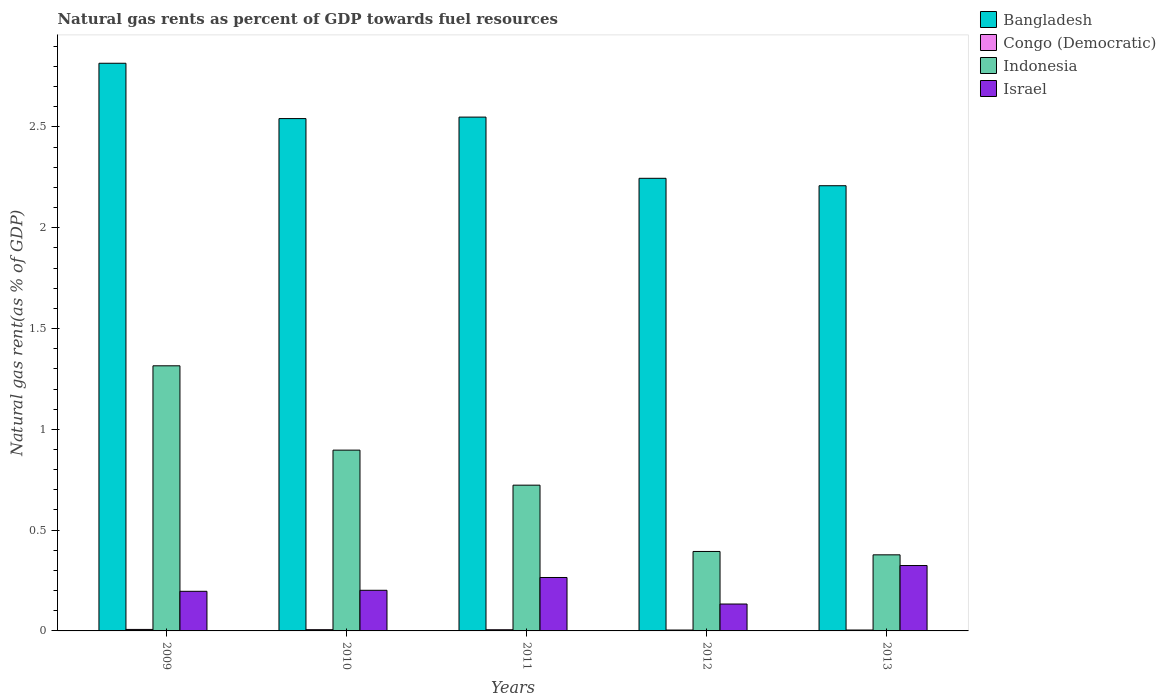How many different coloured bars are there?
Ensure brevity in your answer.  4. Are the number of bars on each tick of the X-axis equal?
Provide a succinct answer. Yes. In how many cases, is the number of bars for a given year not equal to the number of legend labels?
Make the answer very short. 0. What is the natural gas rent in Congo (Democratic) in 2009?
Your answer should be very brief. 0.01. Across all years, what is the maximum natural gas rent in Congo (Democratic)?
Offer a very short reply. 0.01. Across all years, what is the minimum natural gas rent in Bangladesh?
Make the answer very short. 2.21. In which year was the natural gas rent in Israel maximum?
Provide a short and direct response. 2013. In which year was the natural gas rent in Congo (Democratic) minimum?
Ensure brevity in your answer.  2012. What is the total natural gas rent in Indonesia in the graph?
Provide a succinct answer. 3.71. What is the difference between the natural gas rent in Bangladesh in 2011 and that in 2013?
Provide a succinct answer. 0.34. What is the difference between the natural gas rent in Bangladesh in 2011 and the natural gas rent in Israel in 2012?
Your answer should be compact. 2.42. What is the average natural gas rent in Congo (Democratic) per year?
Make the answer very short. 0.01. In the year 2009, what is the difference between the natural gas rent in Israel and natural gas rent in Congo (Democratic)?
Make the answer very short. 0.19. What is the ratio of the natural gas rent in Israel in 2011 to that in 2013?
Provide a short and direct response. 0.82. Is the difference between the natural gas rent in Israel in 2011 and 2012 greater than the difference between the natural gas rent in Congo (Democratic) in 2011 and 2012?
Give a very brief answer. Yes. What is the difference between the highest and the second highest natural gas rent in Israel?
Ensure brevity in your answer.  0.06. What is the difference between the highest and the lowest natural gas rent in Israel?
Give a very brief answer. 0.19. In how many years, is the natural gas rent in Bangladesh greater than the average natural gas rent in Bangladesh taken over all years?
Ensure brevity in your answer.  3. Is the sum of the natural gas rent in Israel in 2011 and 2012 greater than the maximum natural gas rent in Bangladesh across all years?
Ensure brevity in your answer.  No. Is it the case that in every year, the sum of the natural gas rent in Israel and natural gas rent in Bangladesh is greater than the sum of natural gas rent in Indonesia and natural gas rent in Congo (Democratic)?
Offer a terse response. Yes. What does the 1st bar from the right in 2012 represents?
Your response must be concise. Israel. Is it the case that in every year, the sum of the natural gas rent in Bangladesh and natural gas rent in Israel is greater than the natural gas rent in Congo (Democratic)?
Your response must be concise. Yes. How many years are there in the graph?
Provide a succinct answer. 5. What is the difference between two consecutive major ticks on the Y-axis?
Give a very brief answer. 0.5. Are the values on the major ticks of Y-axis written in scientific E-notation?
Your answer should be very brief. No. Does the graph contain grids?
Your answer should be very brief. No. How many legend labels are there?
Make the answer very short. 4. What is the title of the graph?
Keep it short and to the point. Natural gas rents as percent of GDP towards fuel resources. What is the label or title of the Y-axis?
Make the answer very short. Natural gas rent(as % of GDP). What is the Natural gas rent(as % of GDP) in Bangladesh in 2009?
Your response must be concise. 2.82. What is the Natural gas rent(as % of GDP) in Congo (Democratic) in 2009?
Your answer should be compact. 0.01. What is the Natural gas rent(as % of GDP) in Indonesia in 2009?
Make the answer very short. 1.32. What is the Natural gas rent(as % of GDP) of Israel in 2009?
Offer a very short reply. 0.2. What is the Natural gas rent(as % of GDP) in Bangladesh in 2010?
Keep it short and to the point. 2.54. What is the Natural gas rent(as % of GDP) in Congo (Democratic) in 2010?
Provide a short and direct response. 0.01. What is the Natural gas rent(as % of GDP) of Indonesia in 2010?
Make the answer very short. 0.9. What is the Natural gas rent(as % of GDP) in Israel in 2010?
Make the answer very short. 0.2. What is the Natural gas rent(as % of GDP) in Bangladesh in 2011?
Make the answer very short. 2.55. What is the Natural gas rent(as % of GDP) in Congo (Democratic) in 2011?
Give a very brief answer. 0.01. What is the Natural gas rent(as % of GDP) in Indonesia in 2011?
Make the answer very short. 0.72. What is the Natural gas rent(as % of GDP) of Israel in 2011?
Keep it short and to the point. 0.27. What is the Natural gas rent(as % of GDP) of Bangladesh in 2012?
Provide a succinct answer. 2.25. What is the Natural gas rent(as % of GDP) of Congo (Democratic) in 2012?
Provide a succinct answer. 0. What is the Natural gas rent(as % of GDP) in Indonesia in 2012?
Keep it short and to the point. 0.39. What is the Natural gas rent(as % of GDP) of Israel in 2012?
Your answer should be very brief. 0.13. What is the Natural gas rent(as % of GDP) in Bangladesh in 2013?
Your answer should be very brief. 2.21. What is the Natural gas rent(as % of GDP) in Congo (Democratic) in 2013?
Ensure brevity in your answer.  0. What is the Natural gas rent(as % of GDP) in Indonesia in 2013?
Offer a very short reply. 0.38. What is the Natural gas rent(as % of GDP) in Israel in 2013?
Your answer should be compact. 0.32. Across all years, what is the maximum Natural gas rent(as % of GDP) in Bangladesh?
Ensure brevity in your answer.  2.82. Across all years, what is the maximum Natural gas rent(as % of GDP) in Congo (Democratic)?
Keep it short and to the point. 0.01. Across all years, what is the maximum Natural gas rent(as % of GDP) in Indonesia?
Your response must be concise. 1.32. Across all years, what is the maximum Natural gas rent(as % of GDP) in Israel?
Offer a very short reply. 0.32. Across all years, what is the minimum Natural gas rent(as % of GDP) of Bangladesh?
Provide a short and direct response. 2.21. Across all years, what is the minimum Natural gas rent(as % of GDP) in Congo (Democratic)?
Your response must be concise. 0. Across all years, what is the minimum Natural gas rent(as % of GDP) of Indonesia?
Ensure brevity in your answer.  0.38. Across all years, what is the minimum Natural gas rent(as % of GDP) of Israel?
Your answer should be compact. 0.13. What is the total Natural gas rent(as % of GDP) of Bangladesh in the graph?
Offer a terse response. 12.36. What is the total Natural gas rent(as % of GDP) of Congo (Democratic) in the graph?
Make the answer very short. 0.03. What is the total Natural gas rent(as % of GDP) in Indonesia in the graph?
Your answer should be very brief. 3.71. What is the total Natural gas rent(as % of GDP) in Israel in the graph?
Make the answer very short. 1.12. What is the difference between the Natural gas rent(as % of GDP) in Bangladesh in 2009 and that in 2010?
Provide a short and direct response. 0.27. What is the difference between the Natural gas rent(as % of GDP) in Congo (Democratic) in 2009 and that in 2010?
Offer a very short reply. 0. What is the difference between the Natural gas rent(as % of GDP) of Indonesia in 2009 and that in 2010?
Your answer should be very brief. 0.42. What is the difference between the Natural gas rent(as % of GDP) of Israel in 2009 and that in 2010?
Provide a short and direct response. -0.01. What is the difference between the Natural gas rent(as % of GDP) in Bangladesh in 2009 and that in 2011?
Your answer should be compact. 0.27. What is the difference between the Natural gas rent(as % of GDP) in Congo (Democratic) in 2009 and that in 2011?
Your response must be concise. 0. What is the difference between the Natural gas rent(as % of GDP) of Indonesia in 2009 and that in 2011?
Keep it short and to the point. 0.59. What is the difference between the Natural gas rent(as % of GDP) in Israel in 2009 and that in 2011?
Ensure brevity in your answer.  -0.07. What is the difference between the Natural gas rent(as % of GDP) of Bangladesh in 2009 and that in 2012?
Provide a succinct answer. 0.57. What is the difference between the Natural gas rent(as % of GDP) of Congo (Democratic) in 2009 and that in 2012?
Provide a succinct answer. 0. What is the difference between the Natural gas rent(as % of GDP) of Indonesia in 2009 and that in 2012?
Provide a short and direct response. 0.92. What is the difference between the Natural gas rent(as % of GDP) of Israel in 2009 and that in 2012?
Give a very brief answer. 0.06. What is the difference between the Natural gas rent(as % of GDP) in Bangladesh in 2009 and that in 2013?
Give a very brief answer. 0.61. What is the difference between the Natural gas rent(as % of GDP) of Congo (Democratic) in 2009 and that in 2013?
Offer a very short reply. 0. What is the difference between the Natural gas rent(as % of GDP) of Indonesia in 2009 and that in 2013?
Keep it short and to the point. 0.94. What is the difference between the Natural gas rent(as % of GDP) in Israel in 2009 and that in 2013?
Give a very brief answer. -0.13. What is the difference between the Natural gas rent(as % of GDP) of Bangladesh in 2010 and that in 2011?
Give a very brief answer. -0.01. What is the difference between the Natural gas rent(as % of GDP) in Indonesia in 2010 and that in 2011?
Ensure brevity in your answer.  0.17. What is the difference between the Natural gas rent(as % of GDP) of Israel in 2010 and that in 2011?
Give a very brief answer. -0.06. What is the difference between the Natural gas rent(as % of GDP) in Bangladesh in 2010 and that in 2012?
Offer a terse response. 0.3. What is the difference between the Natural gas rent(as % of GDP) in Congo (Democratic) in 2010 and that in 2012?
Provide a succinct answer. 0. What is the difference between the Natural gas rent(as % of GDP) of Indonesia in 2010 and that in 2012?
Ensure brevity in your answer.  0.5. What is the difference between the Natural gas rent(as % of GDP) of Israel in 2010 and that in 2012?
Make the answer very short. 0.07. What is the difference between the Natural gas rent(as % of GDP) of Bangladesh in 2010 and that in 2013?
Provide a short and direct response. 0.33. What is the difference between the Natural gas rent(as % of GDP) of Congo (Democratic) in 2010 and that in 2013?
Ensure brevity in your answer.  0. What is the difference between the Natural gas rent(as % of GDP) of Indonesia in 2010 and that in 2013?
Offer a very short reply. 0.52. What is the difference between the Natural gas rent(as % of GDP) in Israel in 2010 and that in 2013?
Ensure brevity in your answer.  -0.12. What is the difference between the Natural gas rent(as % of GDP) in Bangladesh in 2011 and that in 2012?
Make the answer very short. 0.3. What is the difference between the Natural gas rent(as % of GDP) in Congo (Democratic) in 2011 and that in 2012?
Give a very brief answer. 0. What is the difference between the Natural gas rent(as % of GDP) of Indonesia in 2011 and that in 2012?
Make the answer very short. 0.33. What is the difference between the Natural gas rent(as % of GDP) in Israel in 2011 and that in 2012?
Keep it short and to the point. 0.13. What is the difference between the Natural gas rent(as % of GDP) in Bangladesh in 2011 and that in 2013?
Your answer should be very brief. 0.34. What is the difference between the Natural gas rent(as % of GDP) of Congo (Democratic) in 2011 and that in 2013?
Provide a short and direct response. 0. What is the difference between the Natural gas rent(as % of GDP) of Indonesia in 2011 and that in 2013?
Ensure brevity in your answer.  0.35. What is the difference between the Natural gas rent(as % of GDP) in Israel in 2011 and that in 2013?
Offer a terse response. -0.06. What is the difference between the Natural gas rent(as % of GDP) of Bangladesh in 2012 and that in 2013?
Your answer should be compact. 0.04. What is the difference between the Natural gas rent(as % of GDP) in Congo (Democratic) in 2012 and that in 2013?
Ensure brevity in your answer.  -0. What is the difference between the Natural gas rent(as % of GDP) in Indonesia in 2012 and that in 2013?
Provide a succinct answer. 0.02. What is the difference between the Natural gas rent(as % of GDP) in Israel in 2012 and that in 2013?
Your answer should be compact. -0.19. What is the difference between the Natural gas rent(as % of GDP) of Bangladesh in 2009 and the Natural gas rent(as % of GDP) of Congo (Democratic) in 2010?
Provide a succinct answer. 2.81. What is the difference between the Natural gas rent(as % of GDP) of Bangladesh in 2009 and the Natural gas rent(as % of GDP) of Indonesia in 2010?
Keep it short and to the point. 1.92. What is the difference between the Natural gas rent(as % of GDP) in Bangladesh in 2009 and the Natural gas rent(as % of GDP) in Israel in 2010?
Your response must be concise. 2.61. What is the difference between the Natural gas rent(as % of GDP) of Congo (Democratic) in 2009 and the Natural gas rent(as % of GDP) of Indonesia in 2010?
Ensure brevity in your answer.  -0.89. What is the difference between the Natural gas rent(as % of GDP) in Congo (Democratic) in 2009 and the Natural gas rent(as % of GDP) in Israel in 2010?
Provide a succinct answer. -0.19. What is the difference between the Natural gas rent(as % of GDP) in Indonesia in 2009 and the Natural gas rent(as % of GDP) in Israel in 2010?
Provide a short and direct response. 1.11. What is the difference between the Natural gas rent(as % of GDP) of Bangladesh in 2009 and the Natural gas rent(as % of GDP) of Congo (Democratic) in 2011?
Make the answer very short. 2.81. What is the difference between the Natural gas rent(as % of GDP) in Bangladesh in 2009 and the Natural gas rent(as % of GDP) in Indonesia in 2011?
Provide a short and direct response. 2.09. What is the difference between the Natural gas rent(as % of GDP) of Bangladesh in 2009 and the Natural gas rent(as % of GDP) of Israel in 2011?
Ensure brevity in your answer.  2.55. What is the difference between the Natural gas rent(as % of GDP) of Congo (Democratic) in 2009 and the Natural gas rent(as % of GDP) of Indonesia in 2011?
Your answer should be compact. -0.72. What is the difference between the Natural gas rent(as % of GDP) in Congo (Democratic) in 2009 and the Natural gas rent(as % of GDP) in Israel in 2011?
Give a very brief answer. -0.26. What is the difference between the Natural gas rent(as % of GDP) in Indonesia in 2009 and the Natural gas rent(as % of GDP) in Israel in 2011?
Provide a succinct answer. 1.05. What is the difference between the Natural gas rent(as % of GDP) in Bangladesh in 2009 and the Natural gas rent(as % of GDP) in Congo (Democratic) in 2012?
Provide a succinct answer. 2.81. What is the difference between the Natural gas rent(as % of GDP) in Bangladesh in 2009 and the Natural gas rent(as % of GDP) in Indonesia in 2012?
Make the answer very short. 2.42. What is the difference between the Natural gas rent(as % of GDP) in Bangladesh in 2009 and the Natural gas rent(as % of GDP) in Israel in 2012?
Make the answer very short. 2.68. What is the difference between the Natural gas rent(as % of GDP) of Congo (Democratic) in 2009 and the Natural gas rent(as % of GDP) of Indonesia in 2012?
Your answer should be compact. -0.39. What is the difference between the Natural gas rent(as % of GDP) of Congo (Democratic) in 2009 and the Natural gas rent(as % of GDP) of Israel in 2012?
Offer a very short reply. -0.13. What is the difference between the Natural gas rent(as % of GDP) of Indonesia in 2009 and the Natural gas rent(as % of GDP) of Israel in 2012?
Your response must be concise. 1.18. What is the difference between the Natural gas rent(as % of GDP) in Bangladesh in 2009 and the Natural gas rent(as % of GDP) in Congo (Democratic) in 2013?
Make the answer very short. 2.81. What is the difference between the Natural gas rent(as % of GDP) of Bangladesh in 2009 and the Natural gas rent(as % of GDP) of Indonesia in 2013?
Your response must be concise. 2.44. What is the difference between the Natural gas rent(as % of GDP) in Bangladesh in 2009 and the Natural gas rent(as % of GDP) in Israel in 2013?
Keep it short and to the point. 2.49. What is the difference between the Natural gas rent(as % of GDP) of Congo (Democratic) in 2009 and the Natural gas rent(as % of GDP) of Indonesia in 2013?
Give a very brief answer. -0.37. What is the difference between the Natural gas rent(as % of GDP) of Congo (Democratic) in 2009 and the Natural gas rent(as % of GDP) of Israel in 2013?
Offer a very short reply. -0.32. What is the difference between the Natural gas rent(as % of GDP) in Bangladesh in 2010 and the Natural gas rent(as % of GDP) in Congo (Democratic) in 2011?
Provide a succinct answer. 2.54. What is the difference between the Natural gas rent(as % of GDP) in Bangladesh in 2010 and the Natural gas rent(as % of GDP) in Indonesia in 2011?
Provide a short and direct response. 1.82. What is the difference between the Natural gas rent(as % of GDP) of Bangladesh in 2010 and the Natural gas rent(as % of GDP) of Israel in 2011?
Your answer should be very brief. 2.28. What is the difference between the Natural gas rent(as % of GDP) of Congo (Democratic) in 2010 and the Natural gas rent(as % of GDP) of Indonesia in 2011?
Offer a terse response. -0.72. What is the difference between the Natural gas rent(as % of GDP) in Congo (Democratic) in 2010 and the Natural gas rent(as % of GDP) in Israel in 2011?
Keep it short and to the point. -0.26. What is the difference between the Natural gas rent(as % of GDP) of Indonesia in 2010 and the Natural gas rent(as % of GDP) of Israel in 2011?
Ensure brevity in your answer.  0.63. What is the difference between the Natural gas rent(as % of GDP) in Bangladesh in 2010 and the Natural gas rent(as % of GDP) in Congo (Democratic) in 2012?
Make the answer very short. 2.54. What is the difference between the Natural gas rent(as % of GDP) in Bangladesh in 2010 and the Natural gas rent(as % of GDP) in Indonesia in 2012?
Provide a short and direct response. 2.15. What is the difference between the Natural gas rent(as % of GDP) in Bangladesh in 2010 and the Natural gas rent(as % of GDP) in Israel in 2012?
Keep it short and to the point. 2.41. What is the difference between the Natural gas rent(as % of GDP) of Congo (Democratic) in 2010 and the Natural gas rent(as % of GDP) of Indonesia in 2012?
Offer a terse response. -0.39. What is the difference between the Natural gas rent(as % of GDP) in Congo (Democratic) in 2010 and the Natural gas rent(as % of GDP) in Israel in 2012?
Your answer should be very brief. -0.13. What is the difference between the Natural gas rent(as % of GDP) of Indonesia in 2010 and the Natural gas rent(as % of GDP) of Israel in 2012?
Your response must be concise. 0.76. What is the difference between the Natural gas rent(as % of GDP) in Bangladesh in 2010 and the Natural gas rent(as % of GDP) in Congo (Democratic) in 2013?
Your answer should be very brief. 2.54. What is the difference between the Natural gas rent(as % of GDP) of Bangladesh in 2010 and the Natural gas rent(as % of GDP) of Indonesia in 2013?
Ensure brevity in your answer.  2.16. What is the difference between the Natural gas rent(as % of GDP) of Bangladesh in 2010 and the Natural gas rent(as % of GDP) of Israel in 2013?
Keep it short and to the point. 2.22. What is the difference between the Natural gas rent(as % of GDP) in Congo (Democratic) in 2010 and the Natural gas rent(as % of GDP) in Indonesia in 2013?
Your answer should be very brief. -0.37. What is the difference between the Natural gas rent(as % of GDP) in Congo (Democratic) in 2010 and the Natural gas rent(as % of GDP) in Israel in 2013?
Keep it short and to the point. -0.32. What is the difference between the Natural gas rent(as % of GDP) in Indonesia in 2010 and the Natural gas rent(as % of GDP) in Israel in 2013?
Your answer should be compact. 0.57. What is the difference between the Natural gas rent(as % of GDP) in Bangladesh in 2011 and the Natural gas rent(as % of GDP) in Congo (Democratic) in 2012?
Offer a terse response. 2.54. What is the difference between the Natural gas rent(as % of GDP) in Bangladesh in 2011 and the Natural gas rent(as % of GDP) in Indonesia in 2012?
Keep it short and to the point. 2.15. What is the difference between the Natural gas rent(as % of GDP) in Bangladesh in 2011 and the Natural gas rent(as % of GDP) in Israel in 2012?
Your answer should be very brief. 2.42. What is the difference between the Natural gas rent(as % of GDP) in Congo (Democratic) in 2011 and the Natural gas rent(as % of GDP) in Indonesia in 2012?
Your response must be concise. -0.39. What is the difference between the Natural gas rent(as % of GDP) in Congo (Democratic) in 2011 and the Natural gas rent(as % of GDP) in Israel in 2012?
Offer a terse response. -0.13. What is the difference between the Natural gas rent(as % of GDP) in Indonesia in 2011 and the Natural gas rent(as % of GDP) in Israel in 2012?
Provide a short and direct response. 0.59. What is the difference between the Natural gas rent(as % of GDP) in Bangladesh in 2011 and the Natural gas rent(as % of GDP) in Congo (Democratic) in 2013?
Keep it short and to the point. 2.54. What is the difference between the Natural gas rent(as % of GDP) of Bangladesh in 2011 and the Natural gas rent(as % of GDP) of Indonesia in 2013?
Offer a very short reply. 2.17. What is the difference between the Natural gas rent(as % of GDP) in Bangladesh in 2011 and the Natural gas rent(as % of GDP) in Israel in 2013?
Give a very brief answer. 2.22. What is the difference between the Natural gas rent(as % of GDP) in Congo (Democratic) in 2011 and the Natural gas rent(as % of GDP) in Indonesia in 2013?
Provide a succinct answer. -0.37. What is the difference between the Natural gas rent(as % of GDP) of Congo (Democratic) in 2011 and the Natural gas rent(as % of GDP) of Israel in 2013?
Your answer should be compact. -0.32. What is the difference between the Natural gas rent(as % of GDP) in Indonesia in 2011 and the Natural gas rent(as % of GDP) in Israel in 2013?
Offer a terse response. 0.4. What is the difference between the Natural gas rent(as % of GDP) of Bangladesh in 2012 and the Natural gas rent(as % of GDP) of Congo (Democratic) in 2013?
Your answer should be very brief. 2.24. What is the difference between the Natural gas rent(as % of GDP) in Bangladesh in 2012 and the Natural gas rent(as % of GDP) in Indonesia in 2013?
Ensure brevity in your answer.  1.87. What is the difference between the Natural gas rent(as % of GDP) of Bangladesh in 2012 and the Natural gas rent(as % of GDP) of Israel in 2013?
Ensure brevity in your answer.  1.92. What is the difference between the Natural gas rent(as % of GDP) of Congo (Democratic) in 2012 and the Natural gas rent(as % of GDP) of Indonesia in 2013?
Your answer should be very brief. -0.37. What is the difference between the Natural gas rent(as % of GDP) of Congo (Democratic) in 2012 and the Natural gas rent(as % of GDP) of Israel in 2013?
Ensure brevity in your answer.  -0.32. What is the difference between the Natural gas rent(as % of GDP) in Indonesia in 2012 and the Natural gas rent(as % of GDP) in Israel in 2013?
Your answer should be very brief. 0.07. What is the average Natural gas rent(as % of GDP) in Bangladesh per year?
Make the answer very short. 2.47. What is the average Natural gas rent(as % of GDP) of Congo (Democratic) per year?
Keep it short and to the point. 0.01. What is the average Natural gas rent(as % of GDP) of Indonesia per year?
Offer a terse response. 0.74. What is the average Natural gas rent(as % of GDP) in Israel per year?
Your answer should be very brief. 0.22. In the year 2009, what is the difference between the Natural gas rent(as % of GDP) of Bangladesh and Natural gas rent(as % of GDP) of Congo (Democratic)?
Offer a terse response. 2.81. In the year 2009, what is the difference between the Natural gas rent(as % of GDP) in Bangladesh and Natural gas rent(as % of GDP) in Indonesia?
Keep it short and to the point. 1.5. In the year 2009, what is the difference between the Natural gas rent(as % of GDP) of Bangladesh and Natural gas rent(as % of GDP) of Israel?
Your answer should be compact. 2.62. In the year 2009, what is the difference between the Natural gas rent(as % of GDP) of Congo (Democratic) and Natural gas rent(as % of GDP) of Indonesia?
Your answer should be compact. -1.31. In the year 2009, what is the difference between the Natural gas rent(as % of GDP) of Congo (Democratic) and Natural gas rent(as % of GDP) of Israel?
Keep it short and to the point. -0.19. In the year 2009, what is the difference between the Natural gas rent(as % of GDP) of Indonesia and Natural gas rent(as % of GDP) of Israel?
Provide a succinct answer. 1.12. In the year 2010, what is the difference between the Natural gas rent(as % of GDP) in Bangladesh and Natural gas rent(as % of GDP) in Congo (Democratic)?
Offer a terse response. 2.54. In the year 2010, what is the difference between the Natural gas rent(as % of GDP) of Bangladesh and Natural gas rent(as % of GDP) of Indonesia?
Provide a short and direct response. 1.64. In the year 2010, what is the difference between the Natural gas rent(as % of GDP) of Bangladesh and Natural gas rent(as % of GDP) of Israel?
Your answer should be very brief. 2.34. In the year 2010, what is the difference between the Natural gas rent(as % of GDP) of Congo (Democratic) and Natural gas rent(as % of GDP) of Indonesia?
Provide a short and direct response. -0.89. In the year 2010, what is the difference between the Natural gas rent(as % of GDP) of Congo (Democratic) and Natural gas rent(as % of GDP) of Israel?
Give a very brief answer. -0.2. In the year 2010, what is the difference between the Natural gas rent(as % of GDP) of Indonesia and Natural gas rent(as % of GDP) of Israel?
Give a very brief answer. 0.7. In the year 2011, what is the difference between the Natural gas rent(as % of GDP) of Bangladesh and Natural gas rent(as % of GDP) of Congo (Democratic)?
Your response must be concise. 2.54. In the year 2011, what is the difference between the Natural gas rent(as % of GDP) of Bangladesh and Natural gas rent(as % of GDP) of Indonesia?
Offer a very short reply. 1.83. In the year 2011, what is the difference between the Natural gas rent(as % of GDP) in Bangladesh and Natural gas rent(as % of GDP) in Israel?
Ensure brevity in your answer.  2.28. In the year 2011, what is the difference between the Natural gas rent(as % of GDP) of Congo (Democratic) and Natural gas rent(as % of GDP) of Indonesia?
Keep it short and to the point. -0.72. In the year 2011, what is the difference between the Natural gas rent(as % of GDP) of Congo (Democratic) and Natural gas rent(as % of GDP) of Israel?
Offer a very short reply. -0.26. In the year 2011, what is the difference between the Natural gas rent(as % of GDP) of Indonesia and Natural gas rent(as % of GDP) of Israel?
Offer a very short reply. 0.46. In the year 2012, what is the difference between the Natural gas rent(as % of GDP) of Bangladesh and Natural gas rent(as % of GDP) of Congo (Democratic)?
Provide a succinct answer. 2.24. In the year 2012, what is the difference between the Natural gas rent(as % of GDP) in Bangladesh and Natural gas rent(as % of GDP) in Indonesia?
Provide a succinct answer. 1.85. In the year 2012, what is the difference between the Natural gas rent(as % of GDP) in Bangladesh and Natural gas rent(as % of GDP) in Israel?
Offer a very short reply. 2.11. In the year 2012, what is the difference between the Natural gas rent(as % of GDP) of Congo (Democratic) and Natural gas rent(as % of GDP) of Indonesia?
Give a very brief answer. -0.39. In the year 2012, what is the difference between the Natural gas rent(as % of GDP) in Congo (Democratic) and Natural gas rent(as % of GDP) in Israel?
Your response must be concise. -0.13. In the year 2012, what is the difference between the Natural gas rent(as % of GDP) of Indonesia and Natural gas rent(as % of GDP) of Israel?
Your answer should be compact. 0.26. In the year 2013, what is the difference between the Natural gas rent(as % of GDP) in Bangladesh and Natural gas rent(as % of GDP) in Congo (Democratic)?
Ensure brevity in your answer.  2.2. In the year 2013, what is the difference between the Natural gas rent(as % of GDP) in Bangladesh and Natural gas rent(as % of GDP) in Indonesia?
Keep it short and to the point. 1.83. In the year 2013, what is the difference between the Natural gas rent(as % of GDP) in Bangladesh and Natural gas rent(as % of GDP) in Israel?
Offer a terse response. 1.88. In the year 2013, what is the difference between the Natural gas rent(as % of GDP) in Congo (Democratic) and Natural gas rent(as % of GDP) in Indonesia?
Provide a short and direct response. -0.37. In the year 2013, what is the difference between the Natural gas rent(as % of GDP) of Congo (Democratic) and Natural gas rent(as % of GDP) of Israel?
Ensure brevity in your answer.  -0.32. In the year 2013, what is the difference between the Natural gas rent(as % of GDP) of Indonesia and Natural gas rent(as % of GDP) of Israel?
Provide a succinct answer. 0.05. What is the ratio of the Natural gas rent(as % of GDP) in Bangladesh in 2009 to that in 2010?
Provide a short and direct response. 1.11. What is the ratio of the Natural gas rent(as % of GDP) of Congo (Democratic) in 2009 to that in 2010?
Make the answer very short. 1.2. What is the ratio of the Natural gas rent(as % of GDP) in Indonesia in 2009 to that in 2010?
Keep it short and to the point. 1.47. What is the ratio of the Natural gas rent(as % of GDP) in Israel in 2009 to that in 2010?
Make the answer very short. 0.97. What is the ratio of the Natural gas rent(as % of GDP) of Bangladesh in 2009 to that in 2011?
Your answer should be compact. 1.1. What is the ratio of the Natural gas rent(as % of GDP) in Congo (Democratic) in 2009 to that in 2011?
Make the answer very short. 1.25. What is the ratio of the Natural gas rent(as % of GDP) of Indonesia in 2009 to that in 2011?
Offer a very short reply. 1.82. What is the ratio of the Natural gas rent(as % of GDP) of Israel in 2009 to that in 2011?
Provide a short and direct response. 0.74. What is the ratio of the Natural gas rent(as % of GDP) of Bangladesh in 2009 to that in 2012?
Keep it short and to the point. 1.25. What is the ratio of the Natural gas rent(as % of GDP) of Congo (Democratic) in 2009 to that in 2012?
Keep it short and to the point. 1.67. What is the ratio of the Natural gas rent(as % of GDP) in Indonesia in 2009 to that in 2012?
Offer a terse response. 3.34. What is the ratio of the Natural gas rent(as % of GDP) of Israel in 2009 to that in 2012?
Your answer should be compact. 1.47. What is the ratio of the Natural gas rent(as % of GDP) in Bangladesh in 2009 to that in 2013?
Provide a short and direct response. 1.28. What is the ratio of the Natural gas rent(as % of GDP) of Congo (Democratic) in 2009 to that in 2013?
Your answer should be compact. 1.66. What is the ratio of the Natural gas rent(as % of GDP) in Indonesia in 2009 to that in 2013?
Keep it short and to the point. 3.48. What is the ratio of the Natural gas rent(as % of GDP) in Israel in 2009 to that in 2013?
Ensure brevity in your answer.  0.61. What is the ratio of the Natural gas rent(as % of GDP) of Congo (Democratic) in 2010 to that in 2011?
Keep it short and to the point. 1.05. What is the ratio of the Natural gas rent(as % of GDP) in Indonesia in 2010 to that in 2011?
Your response must be concise. 1.24. What is the ratio of the Natural gas rent(as % of GDP) in Israel in 2010 to that in 2011?
Give a very brief answer. 0.76. What is the ratio of the Natural gas rent(as % of GDP) in Bangladesh in 2010 to that in 2012?
Provide a succinct answer. 1.13. What is the ratio of the Natural gas rent(as % of GDP) in Congo (Democratic) in 2010 to that in 2012?
Provide a short and direct response. 1.4. What is the ratio of the Natural gas rent(as % of GDP) of Indonesia in 2010 to that in 2012?
Offer a very short reply. 2.28. What is the ratio of the Natural gas rent(as % of GDP) in Israel in 2010 to that in 2012?
Keep it short and to the point. 1.51. What is the ratio of the Natural gas rent(as % of GDP) of Bangladesh in 2010 to that in 2013?
Offer a terse response. 1.15. What is the ratio of the Natural gas rent(as % of GDP) in Congo (Democratic) in 2010 to that in 2013?
Your response must be concise. 1.39. What is the ratio of the Natural gas rent(as % of GDP) of Indonesia in 2010 to that in 2013?
Offer a very short reply. 2.38. What is the ratio of the Natural gas rent(as % of GDP) of Israel in 2010 to that in 2013?
Offer a very short reply. 0.62. What is the ratio of the Natural gas rent(as % of GDP) of Bangladesh in 2011 to that in 2012?
Offer a terse response. 1.14. What is the ratio of the Natural gas rent(as % of GDP) of Congo (Democratic) in 2011 to that in 2012?
Your answer should be very brief. 1.33. What is the ratio of the Natural gas rent(as % of GDP) of Indonesia in 2011 to that in 2012?
Your answer should be very brief. 1.83. What is the ratio of the Natural gas rent(as % of GDP) in Israel in 2011 to that in 2012?
Provide a short and direct response. 1.99. What is the ratio of the Natural gas rent(as % of GDP) in Bangladesh in 2011 to that in 2013?
Offer a terse response. 1.15. What is the ratio of the Natural gas rent(as % of GDP) in Congo (Democratic) in 2011 to that in 2013?
Your answer should be compact. 1.33. What is the ratio of the Natural gas rent(as % of GDP) of Indonesia in 2011 to that in 2013?
Keep it short and to the point. 1.92. What is the ratio of the Natural gas rent(as % of GDP) of Israel in 2011 to that in 2013?
Offer a terse response. 0.82. What is the ratio of the Natural gas rent(as % of GDP) of Bangladesh in 2012 to that in 2013?
Offer a terse response. 1.02. What is the ratio of the Natural gas rent(as % of GDP) of Indonesia in 2012 to that in 2013?
Provide a short and direct response. 1.04. What is the ratio of the Natural gas rent(as % of GDP) of Israel in 2012 to that in 2013?
Give a very brief answer. 0.41. What is the difference between the highest and the second highest Natural gas rent(as % of GDP) of Bangladesh?
Offer a very short reply. 0.27. What is the difference between the highest and the second highest Natural gas rent(as % of GDP) of Congo (Democratic)?
Offer a very short reply. 0. What is the difference between the highest and the second highest Natural gas rent(as % of GDP) of Indonesia?
Ensure brevity in your answer.  0.42. What is the difference between the highest and the second highest Natural gas rent(as % of GDP) in Israel?
Provide a succinct answer. 0.06. What is the difference between the highest and the lowest Natural gas rent(as % of GDP) of Bangladesh?
Your answer should be very brief. 0.61. What is the difference between the highest and the lowest Natural gas rent(as % of GDP) of Congo (Democratic)?
Offer a very short reply. 0. What is the difference between the highest and the lowest Natural gas rent(as % of GDP) in Indonesia?
Keep it short and to the point. 0.94. What is the difference between the highest and the lowest Natural gas rent(as % of GDP) in Israel?
Offer a very short reply. 0.19. 